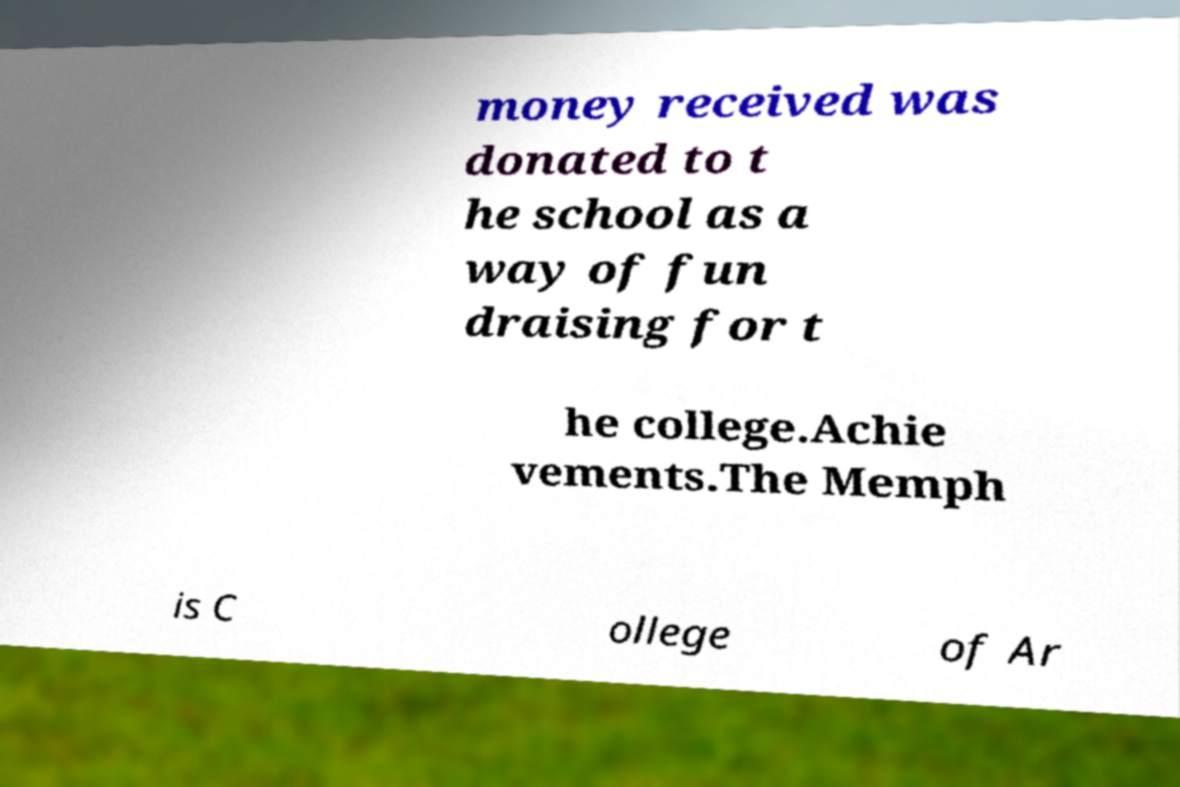Could you assist in decoding the text presented in this image and type it out clearly? money received was donated to t he school as a way of fun draising for t he college.Achie vements.The Memph is C ollege of Ar 